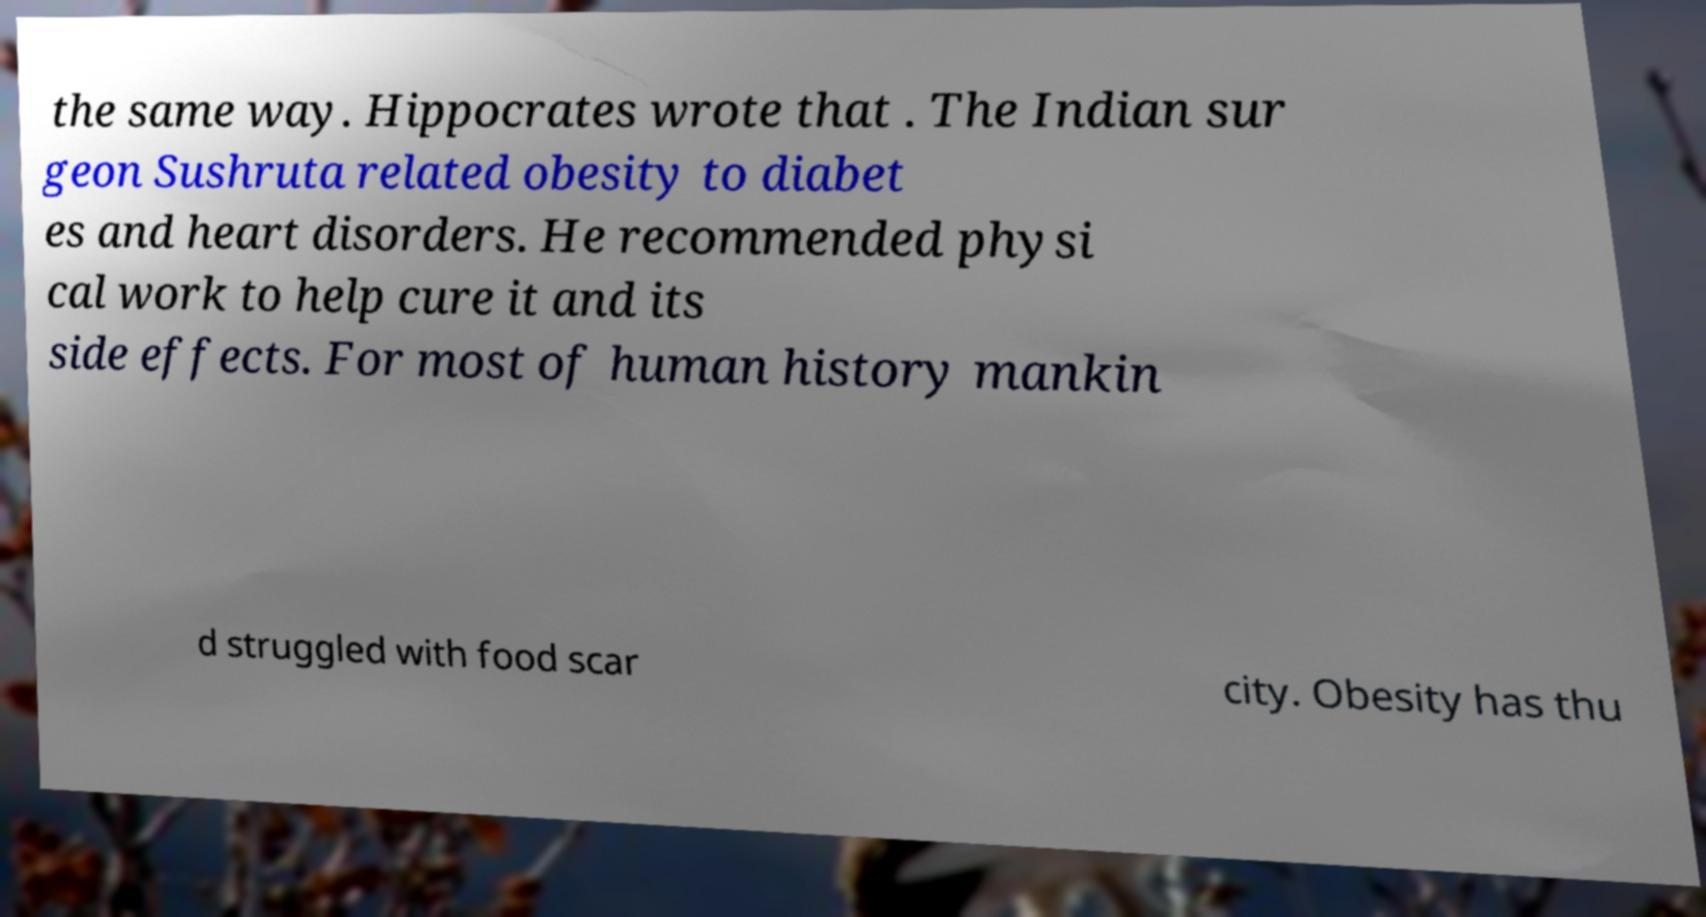Can you accurately transcribe the text from the provided image for me? the same way. Hippocrates wrote that . The Indian sur geon Sushruta related obesity to diabet es and heart disorders. He recommended physi cal work to help cure it and its side effects. For most of human history mankin d struggled with food scar city. Obesity has thu 